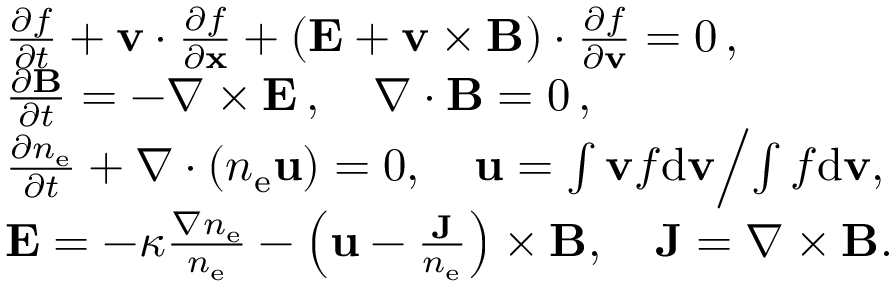<formula> <loc_0><loc_0><loc_500><loc_500>\begin{array} { r l } & { \frac { \partial f } { \partial t } + { \mathbf v } \cdot \frac { \partial f } { \partial x } + ( { \mathbf E } + { \mathbf v } \times { B } ) \cdot \frac { \partial f } { \partial { \mathbf v } } = 0 \, , } \\ & { \frac { \partial B } { \partial t } = - \nabla \times { \mathbf E } \, , \quad \nabla \cdot B = 0 \, , } \\ & { \frac { \partial n _ { e } } { \partial t } + \nabla \cdot \left ( n _ { e } \mathbf u \right ) = 0 , \quad \mathbf u = { \int { \mathbf v } f d { \mathbf v } } \Big / { \int f d { \mathbf v } } , } \\ & { { \mathbf E } = - \kappa \frac { \nabla n _ { e } } { n _ { e } } - \left ( \mathbf u - \frac { \mathbf J } { n _ { e } } \right ) \times { B } , \quad \mathbf J = \nabla \times { \mathbf B } . } \end{array}</formula> 